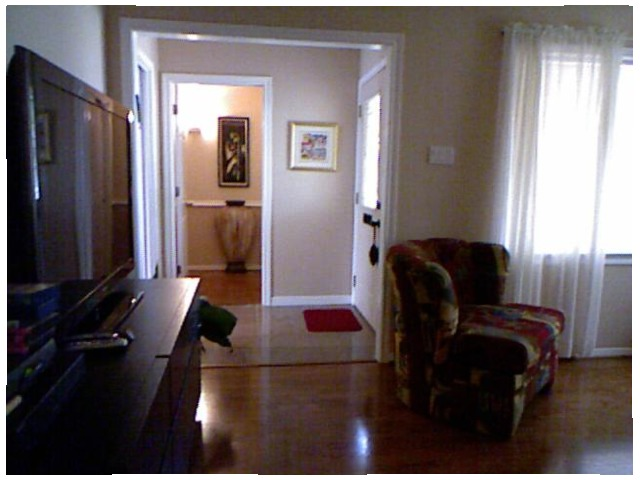<image>
Can you confirm if the mat is behind the sofa? Yes. From this viewpoint, the mat is positioned behind the sofa, with the sofa partially or fully occluding the mat. 